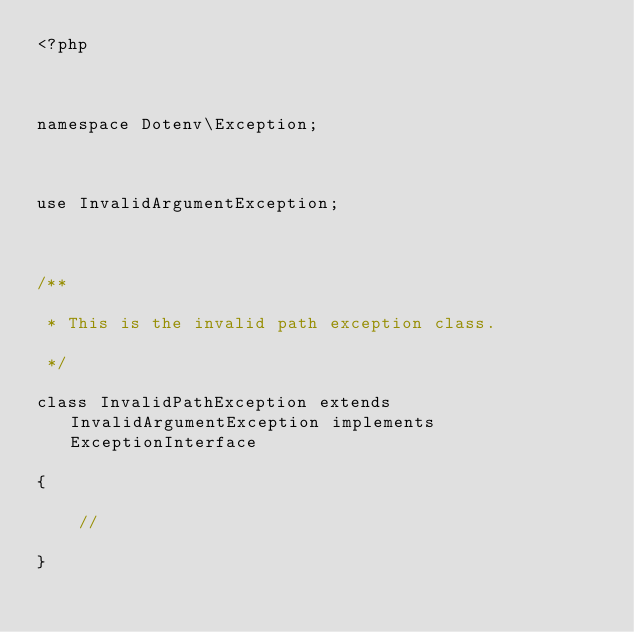<code> <loc_0><loc_0><loc_500><loc_500><_PHP_><?php

namespace Dotenv\Exception;

use InvalidArgumentException;

/**
 * This is the invalid path exception class.
 */
class InvalidPathException extends InvalidArgumentException implements ExceptionInterface
{
    //
}
</code> 